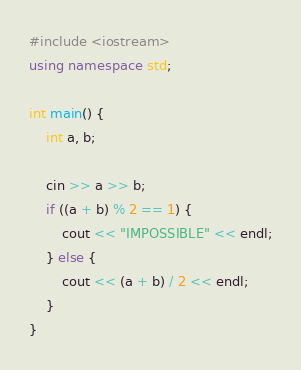Convert code to text. <code><loc_0><loc_0><loc_500><loc_500><_C++_>#include <iostream>
using namespace std;

int main() {
    int a, b;
    
    cin >> a >> b;
    if ((a + b) % 2 == 1) {
        cout << "IMPOSSIBLE" << endl;
    } else {
        cout << (a + b) / 2 << endl;
    }
}
</code> 